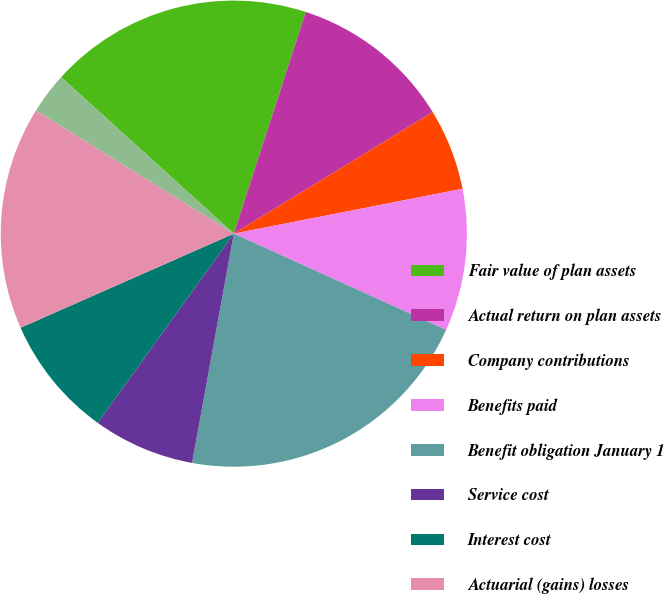Convert chart to OTSL. <chart><loc_0><loc_0><loc_500><loc_500><pie_chart><fcel>Fair value of plan assets<fcel>Actual return on plan assets<fcel>Company contributions<fcel>Benefits paid<fcel>Benefit obligation January 1<fcel>Service cost<fcel>Interest cost<fcel>Actuarial (gains) losses<fcel>Plan amendments<nl><fcel>18.28%<fcel>11.27%<fcel>5.65%<fcel>9.86%<fcel>21.09%<fcel>7.06%<fcel>8.46%<fcel>15.48%<fcel>2.85%<nl></chart> 